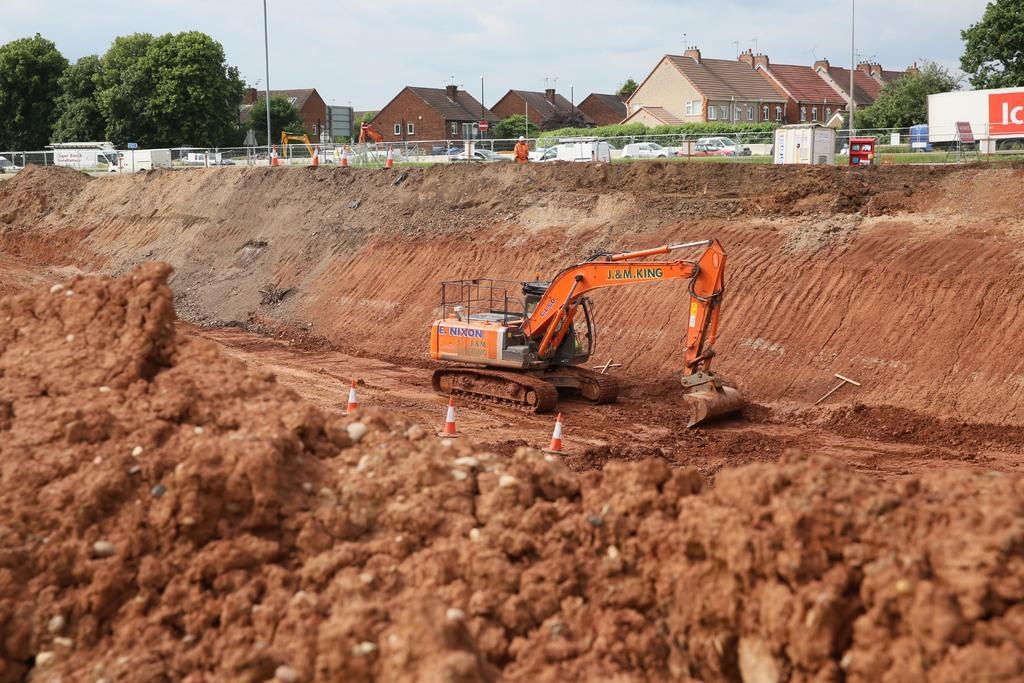In one or two sentences, can you explain what this image depicts? In the center of the image we can see a crane excavating the land. We can see traffic cones and soil. In the background there are trees, fence, sheds, board and sky and there are cars. 